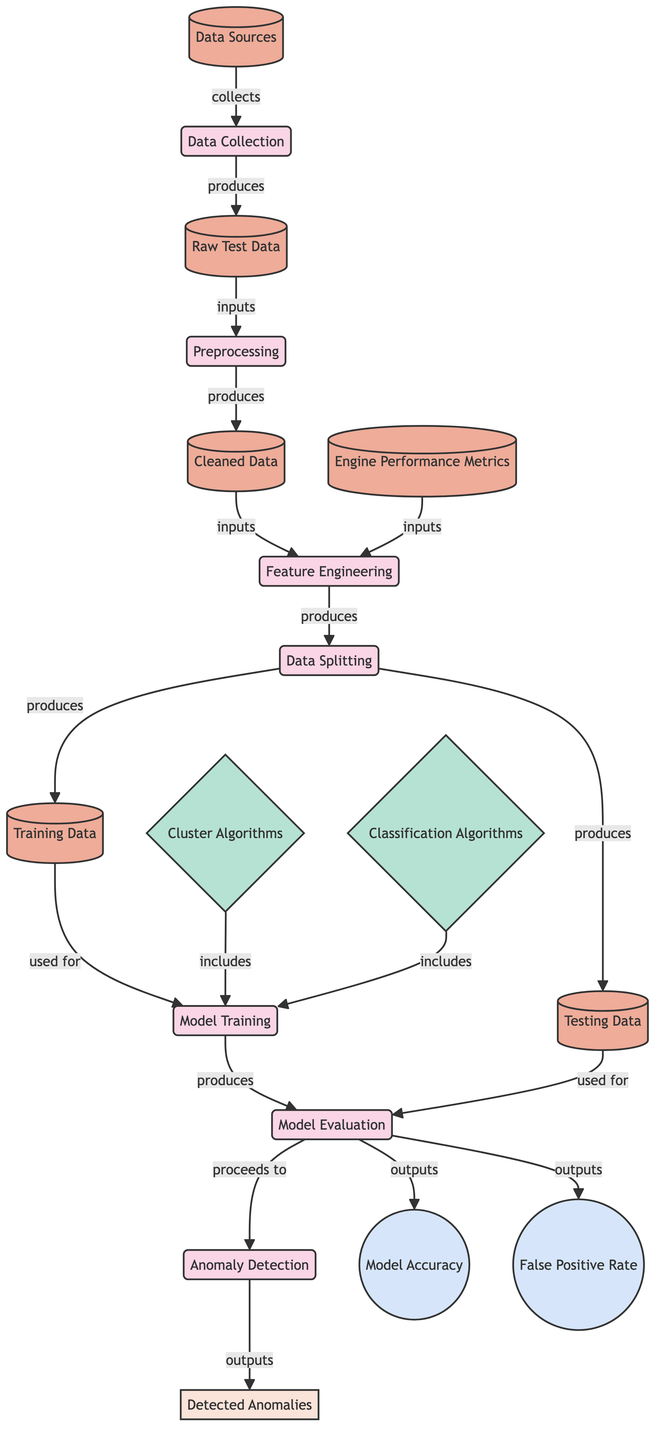What is the first process in the diagram? The first process is labeled as "Data Collection," which is indicated as node 1 in the diagram.
Answer: Data Collection How many data sources are identified in the diagram? The diagram mentions one node labeled "Data Sources," indicating a single data source.
Answer: One What type of data is produced after preprocessing? After preprocessing, the produced data is labeled as "Cleaned Data," which is node 10 in the diagram.
Answer: Cleaned Data Which algorithms are included in the model training step? The diagram lists "Cluster Algorithms" and "Classification Algorithms" as the algorithms used for model training, which are displayed as node 12 and node 13 respectively.
Answer: Cluster Algorithms, Classification Algorithms What metrics are evaluated after model training? The diagram shows two metrics evaluated after model training: "Model Accuracy" and "False Positive Rate," corresponding to node 16 and node 17 respectively.
Answer: Model Accuracy, False Positive Rate Which node produces the training and testing data? The node labeled "Data Splitting" produces both "Training Data" and "Testing Data," which are nodes 14 and 15 in the diagram.
Answer: Data Splitting How does the output of the model evaluation feed into anomaly detection? The model evaluation outputs "Model Accuracy" and "False Positive Rate," which proceed to the anomaly detection as indicated by the flow from node 6 to node 7.
Answer: Outputs of Model Evaluation What is the final output of the diagram? The final output indicated in the diagram is labeled "Detected Anomalies," which corresponds to node 18.
Answer: Detected Anomalies What type of data is indicated as an input to feature engineering? The inputs to feature engineering include "Cleaned Data" and "Engine Performance Metrics," represented by nodes 10 and 11.
Answer: Cleaned Data, Engine Performance Metrics What step immediately follows model evaluation? The step immediately following model evaluation is "Anomaly Detection," as indicated by the flow from node 6 to node 7.
Answer: Anomaly Detection 